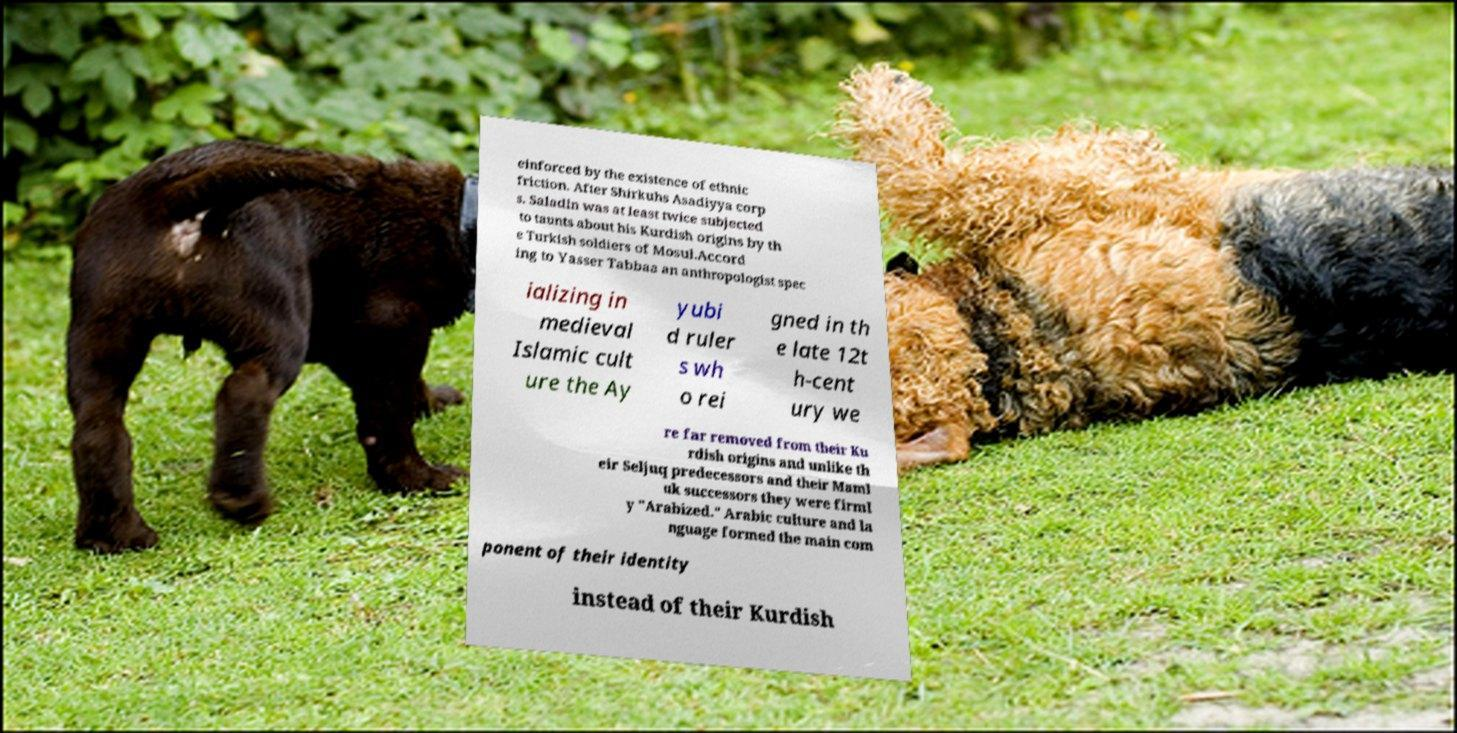Can you read and provide the text displayed in the image?This photo seems to have some interesting text. Can you extract and type it out for me? einforced by the existence of ethnic friction. After Shirkuhs Asadiyya corp s. Saladin was at least twice subjected to taunts about his Kurdish origins by th e Turkish soldiers of Mosul.Accord ing to Yasser Tabbaa an anthropologist spec ializing in medieval Islamic cult ure the Ay yubi d ruler s wh o rei gned in th e late 12t h-cent ury we re far removed from their Ku rdish origins and unlike th eir Seljuq predecessors and their Maml uk successors they were firml y "Arabized." Arabic culture and la nguage formed the main com ponent of their identity instead of their Kurdish 